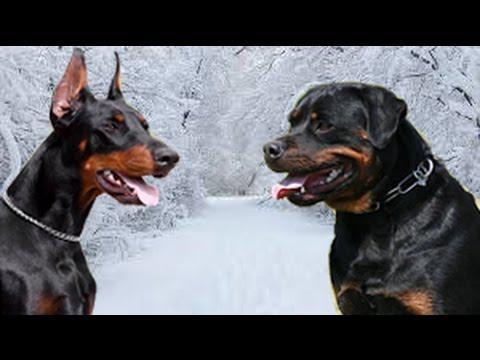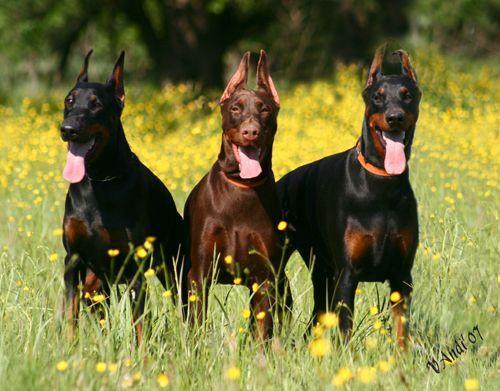The first image is the image on the left, the second image is the image on the right. Examine the images to the left and right. Is the description "One picture has only three dogs posing together." accurate? Answer yes or no. Yes. The first image is the image on the left, the second image is the image on the right. Assess this claim about the two images: "There are exactly five dogs in total.". Correct or not? Answer yes or no. Yes. 